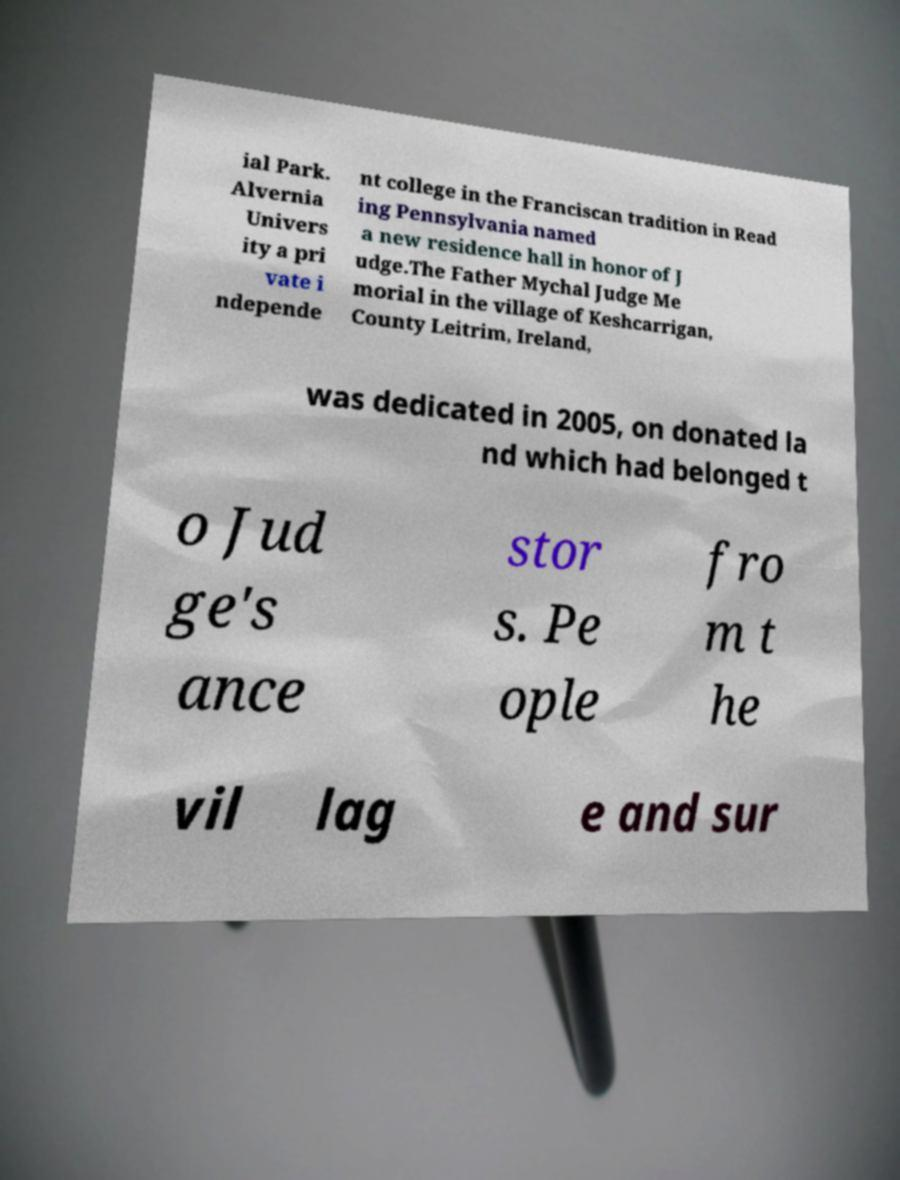I need the written content from this picture converted into text. Can you do that? ial Park. Alvernia Univers ity a pri vate i ndepende nt college in the Franciscan tradition in Read ing Pennsylvania named a new residence hall in honor of J udge.The Father Mychal Judge Me morial in the village of Keshcarrigan, County Leitrim, Ireland, was dedicated in 2005, on donated la nd which had belonged t o Jud ge's ance stor s. Pe ople fro m t he vil lag e and sur 